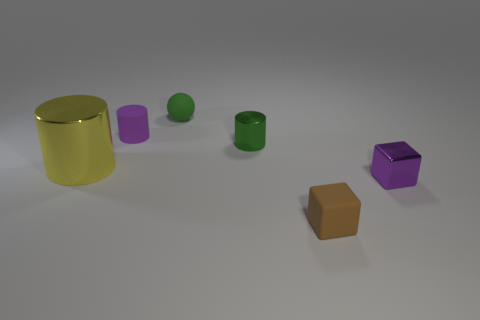Add 3 big metal cylinders. How many objects exist? 9 Subtract all blocks. How many objects are left? 4 Add 1 tiny shiny blocks. How many tiny shiny blocks exist? 2 Subtract 1 purple blocks. How many objects are left? 5 Subtract all small red rubber balls. Subtract all tiny green objects. How many objects are left? 4 Add 5 small brown objects. How many small brown objects are left? 6 